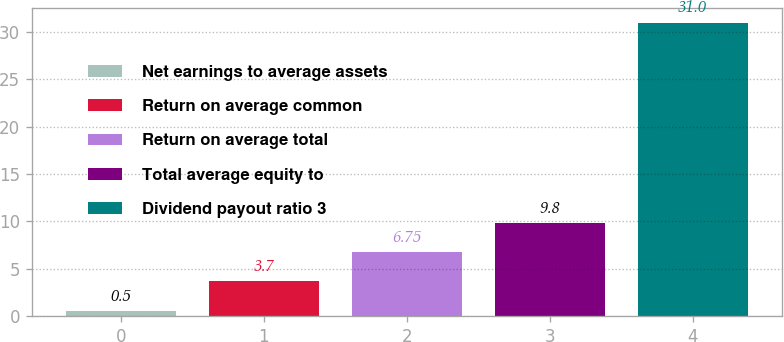<chart> <loc_0><loc_0><loc_500><loc_500><bar_chart><fcel>Net earnings to average assets<fcel>Return on average common<fcel>Return on average total<fcel>Total average equity to<fcel>Dividend payout ratio 3<nl><fcel>0.5<fcel>3.7<fcel>6.75<fcel>9.8<fcel>31<nl></chart> 